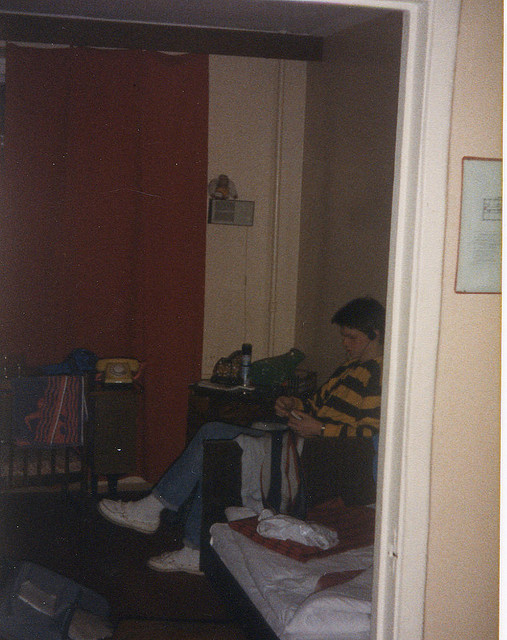<image>What console is this person using? It is ambiguous what console the person is using. It could be a playstation, wii, xbox, ipod, or gameboy. What console is this person using? I am not sure what console this person is using. It can be seen Wii, Xbox, or Gameboy. 